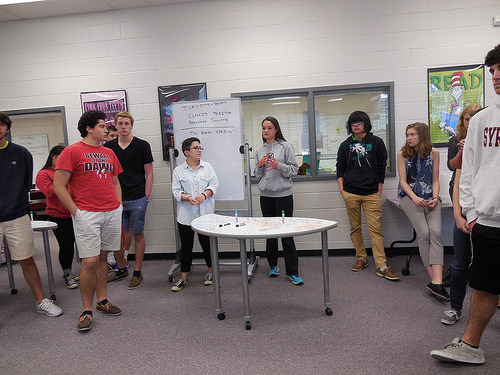<image>
Can you confirm if the woman is in front of the man? No. The woman is not in front of the man. The spatial positioning shows a different relationship between these objects. 